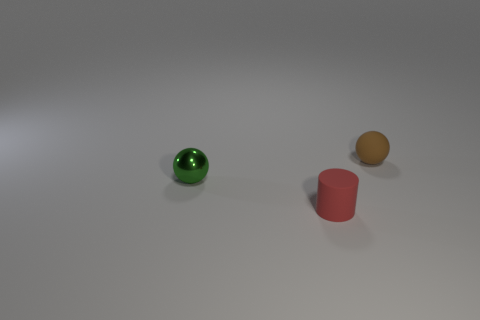Are there more green balls than tiny rubber things?
Offer a terse response. No. What is the size of the object on the right side of the small matte object in front of the small green object?
Your answer should be compact. Small. There is a matte thing that is the same shape as the green shiny thing; what color is it?
Your answer should be very brief. Brown. The metallic object has what size?
Your response must be concise. Small. How many cylinders are purple shiny objects or red things?
Make the answer very short. 1. What is the size of the brown thing that is the same shape as the green metallic thing?
Provide a short and direct response. Small. How many green shiny objects are there?
Your answer should be compact. 1. There is a small green shiny object; is it the same shape as the small thing that is in front of the green sphere?
Make the answer very short. No. How big is the matte thing that is in front of the tiny brown ball?
Offer a very short reply. Small. What is the material of the tiny cylinder?
Your answer should be very brief. Rubber. 